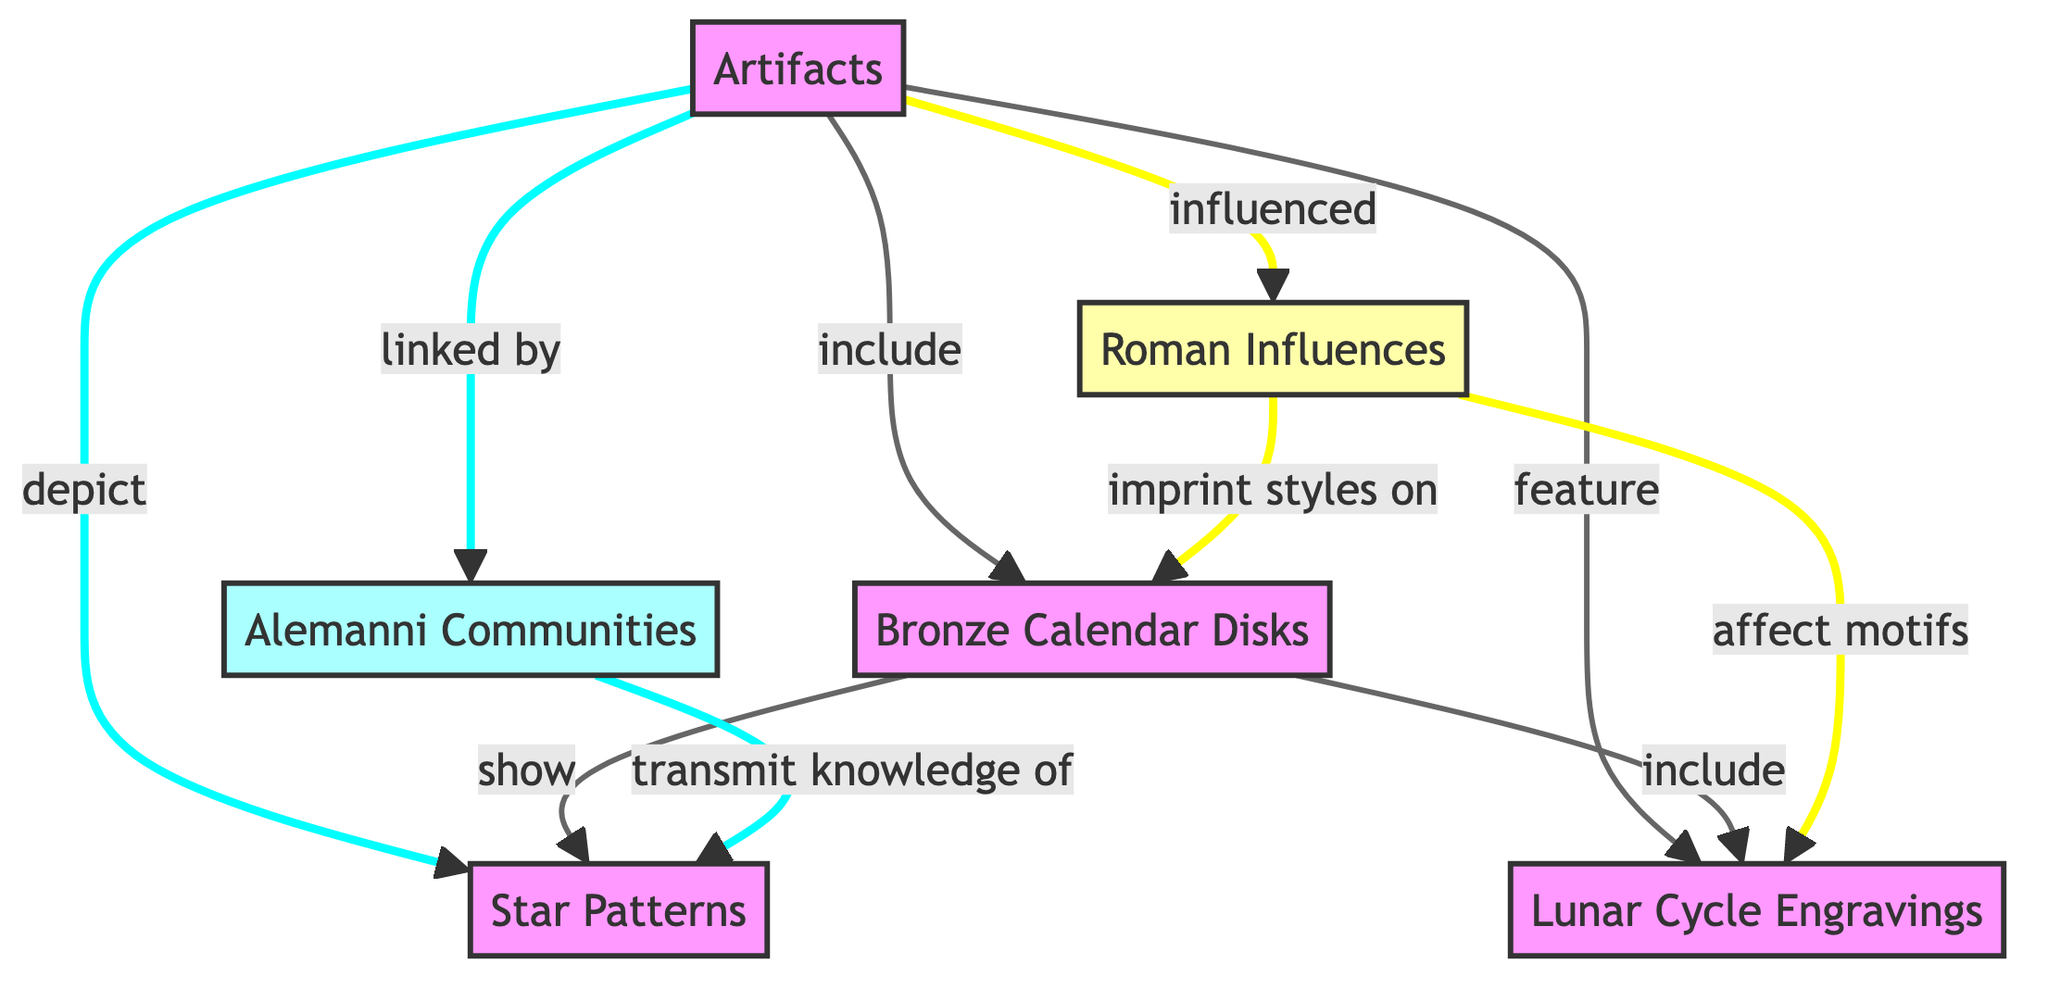What types of artifacts are included in the diagram? The diagram includes "Bronze Calendar Disks" as the specific type of artifact related to celestial observations. This is indicated by a direct connection from "Artifacts" to "Bronze Calendar Disks".
Answer: Bronze Calendar Disks How many nodes are present in the diagram? The diagram features six distinct nodes: Artifacts, Bronze Calendar Disks, Alemanni Communities, Star Patterns, Lunar Cycle Engravings, and Roman Influences. Counting each type shown gives a total of six nodes.
Answer: 6 What do the Bronze Calendar Disks show? The diagram indicates that the "Bronze Calendar Disks" "show" "Star Patterns". This is a direct link indicated in the flowchart.
Answer: Star Patterns Which community is linked by the artifacts? The artifacts are linked by "Alemanni Communities", as depicted by the flow from "Artifacts" to that node in the diagram.
Answer: Alemanni Communities How do Roman influences affect the artifacts? "Roman Influences" "imprint styles on" the "Bronze Calendar Disks" and also "affect motifs" on "Lunar Cycle Engravings", indicating a direct influence on multiple aspects of the artifacts.
Answer: imprint styles What knowledge do Alemanni Communities transmit? The Alemanni Communities transmit knowledge of "Star Patterns" as shown by the link from "Alemanni Communities" to "Star Patterns" in the diagram.
Answer: Star Patterns How many direct relationships are there connected to Bronze Calendar Disks? The "Bronze Calendar Disks" have three direct relationships linked to them: they "show" Star Patterns, they "include" Lunar Cycle Engravings, and they are "influenced" by Roman influences. Therefore, there are three connections.
Answer: 3 What types of engravings are featured in the artifacts? The artifacts feature "Lunar Cycle Engravings" as indicated by the connection from "Artifacts" to "Lunar Cycle Engravings" in the diagram.
Answer: Lunar Cycle Engravings What influences the motifs in Lunar Cycle Engravings? The motifs in "Lunar Cycle Engravings" are affected by "Roman Influences", as shown by the link connecting "Roman Influences" to "Lunar Cycle Engravings".
Answer: Roman Influences 